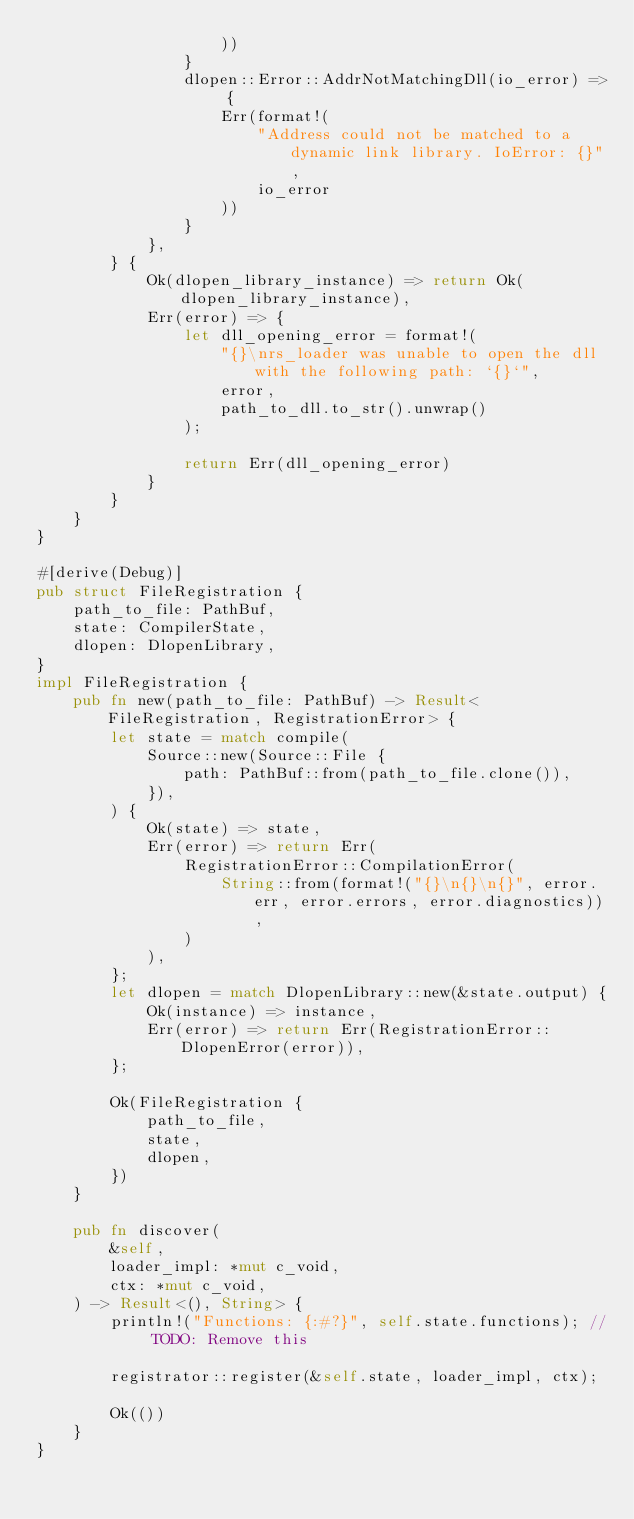<code> <loc_0><loc_0><loc_500><loc_500><_Rust_>                    ))
                }
                dlopen::Error::AddrNotMatchingDll(io_error) => {
                    Err(format!(
                        "Address could not be matched to a dynamic link library. IoError: {}",
                        io_error
                    ))
                }
            },
        } {
            Ok(dlopen_library_instance) => return Ok(dlopen_library_instance),
            Err(error) => {
                let dll_opening_error = format!(
                    "{}\nrs_loader was unable to open the dll with the following path: `{}`", 
                    error,
                    path_to_dll.to_str().unwrap()
                );

                return Err(dll_opening_error)
            }
        }
    }
}

#[derive(Debug)]
pub struct FileRegistration {
    path_to_file: PathBuf,
    state: CompilerState,
    dlopen: DlopenLibrary,
}
impl FileRegistration {
    pub fn new(path_to_file: PathBuf) -> Result<FileRegistration, RegistrationError> {
        let state = match compile(
            Source::new(Source::File {
                path: PathBuf::from(path_to_file.clone()),
            }),
        ) {
            Ok(state) => state,
            Err(error) => return Err(
                RegistrationError::CompilationError(
                    String::from(format!("{}\n{}\n{}", error.err, error.errors, error.diagnostics)),
                )
            ),
        };
        let dlopen = match DlopenLibrary::new(&state.output) {
            Ok(instance) => instance,
            Err(error) => return Err(RegistrationError::DlopenError(error)),
        };

        Ok(FileRegistration {
            path_to_file,
            state,
            dlopen,
        })
    }

    pub fn discover(
        &self,
        loader_impl: *mut c_void,
        ctx: *mut c_void,
    ) -> Result<(), String> {
        println!("Functions: {:#?}", self.state.functions); // TODO: Remove this

        registrator::register(&self.state, loader_impl, ctx);

        Ok(())
    }
}
</code> 